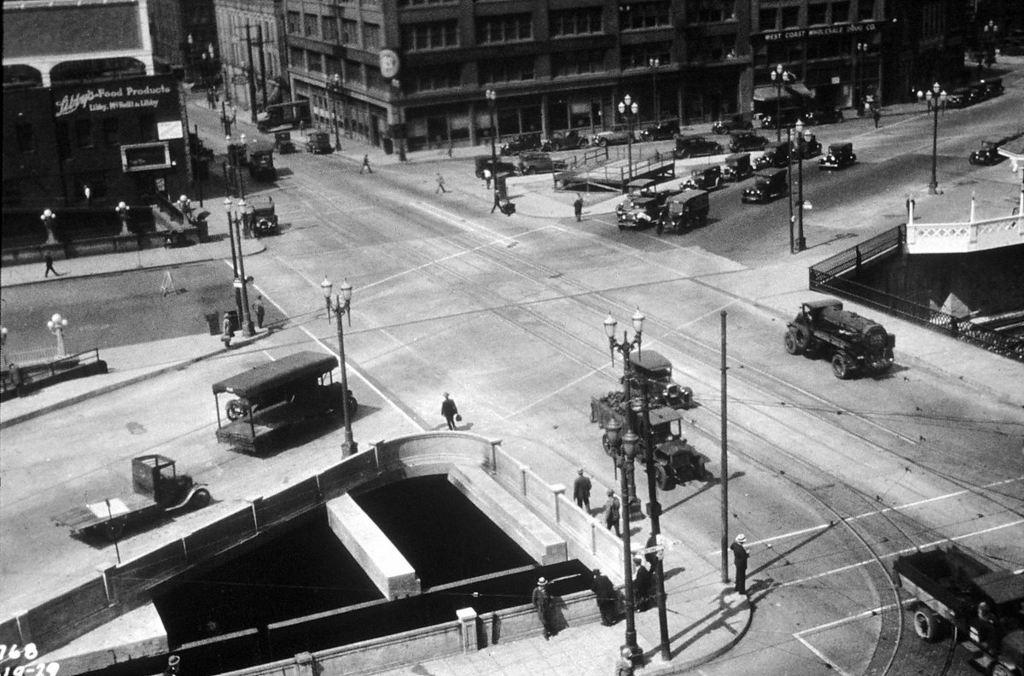What is the color scheme of the image? The image is black and white. What can be seen on the roads in the image? There are vehicles on the roads in the image. How many people are visible in the image? There are many people in the image. What structures can be seen in the image? There are light poles and buildings in the image. What type of architectural feature is present in the image? There are railings in the image. Where is the honey being stored in the image? There is no honey present in the image. What type of toy can be seen in the hands of the people in the image? There are no toys visible in the image; people are not holding any objects. 